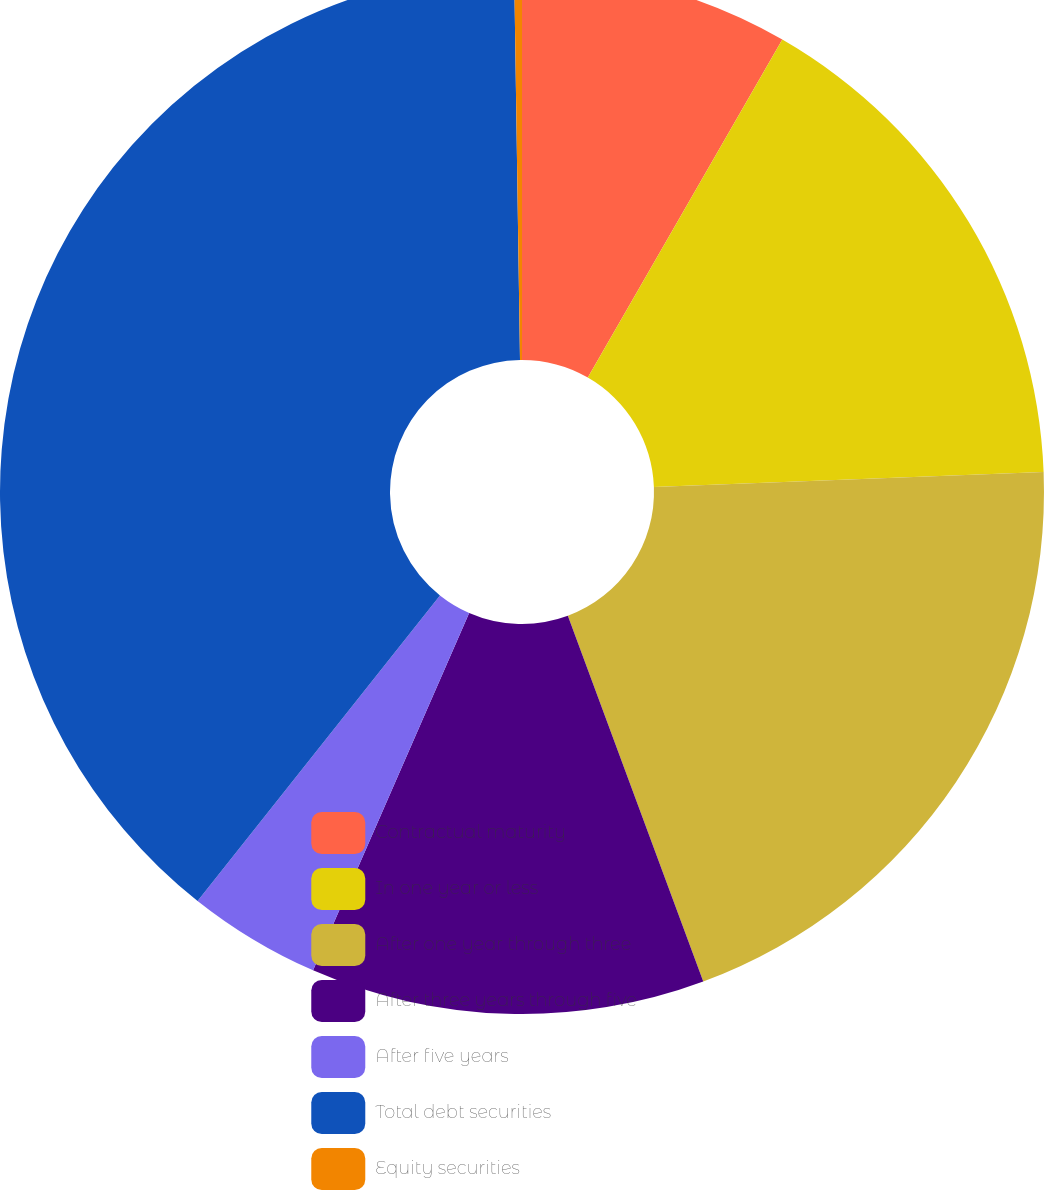Convert chart. <chart><loc_0><loc_0><loc_500><loc_500><pie_chart><fcel>Contractual maturity<fcel>In one year or less<fcel>After one year through three<fcel>After three years through five<fcel>After five years<fcel>Total debt securities<fcel>Equity securities<nl><fcel>8.31%<fcel>16.08%<fcel>19.97%<fcel>12.2%<fcel>4.12%<fcel>39.09%<fcel>0.24%<nl></chart> 